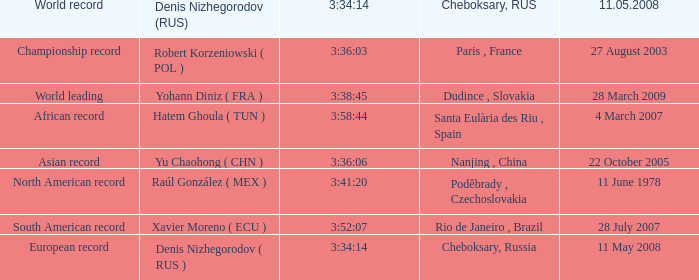When 3:38:45 is  3:34:14 what is the date on May 11th, 2008? 28 March 2009. 